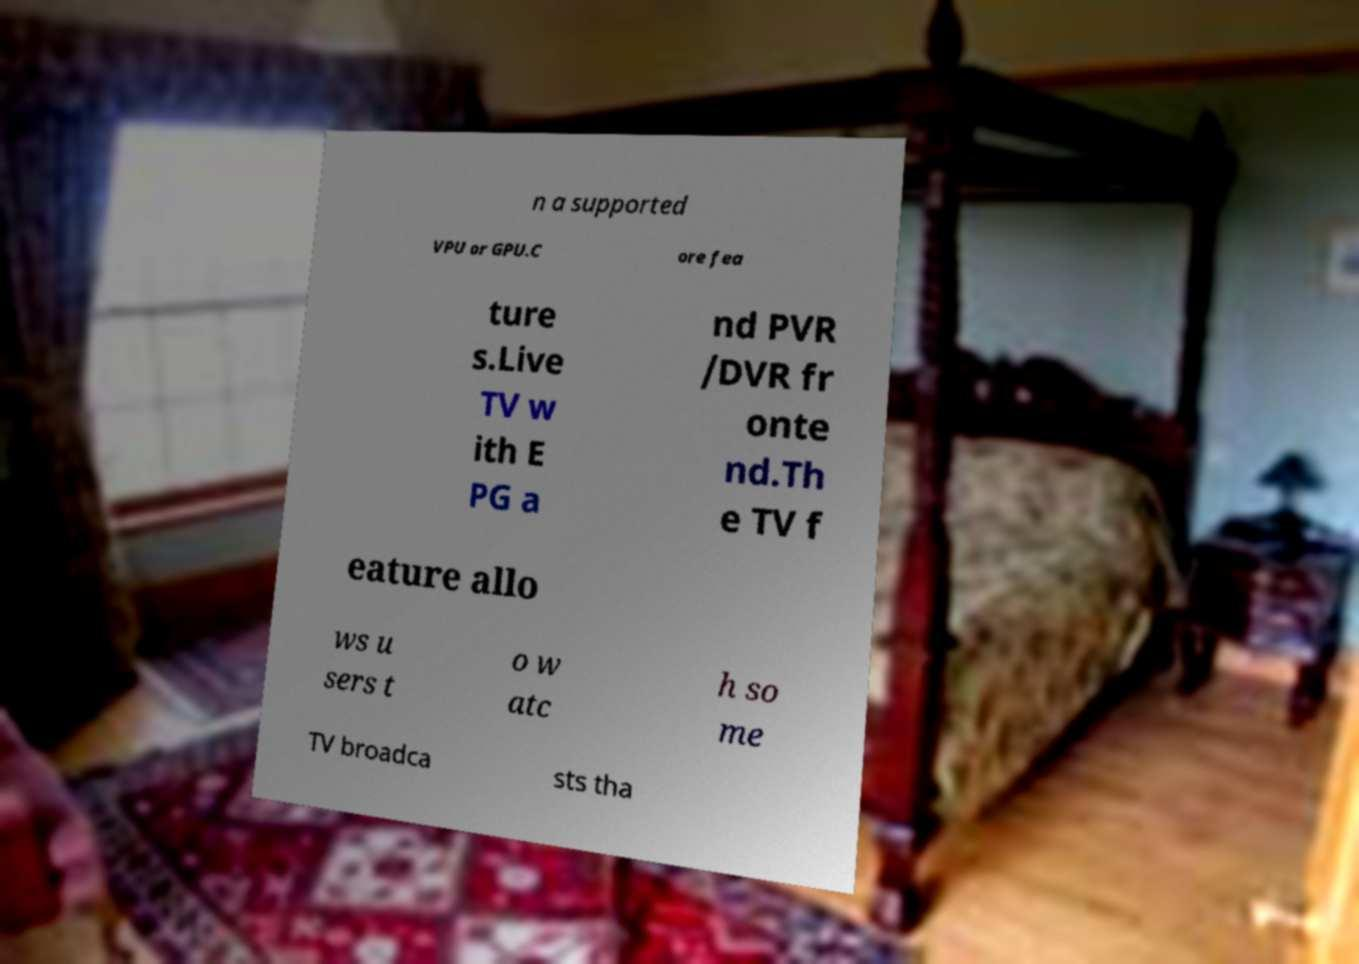Please read and relay the text visible in this image. What does it say? n a supported VPU or GPU.C ore fea ture s.Live TV w ith E PG a nd PVR /DVR fr onte nd.Th e TV f eature allo ws u sers t o w atc h so me TV broadca sts tha 